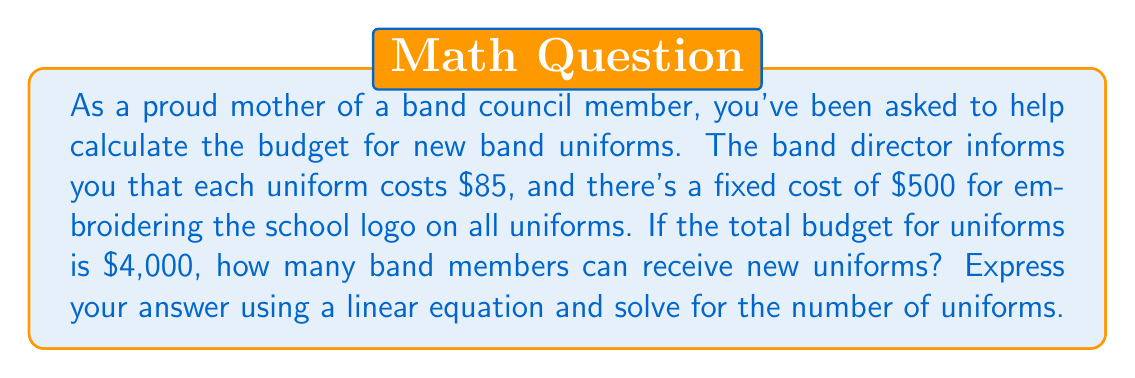Show me your answer to this math problem. Let's approach this step-by-step:

1) Let $x$ represent the number of uniforms.

2) We can express the total cost as a linear equation:
   $$ \text{Total Cost} = \text{Fixed Cost} + (\text{Cost per Uniform} \times \text{Number of Uniforms}) $$

3) Substituting the given values:
   $$ 4000 = 500 + 85x $$

4) To solve for $x$, first subtract 500 from both sides:
   $$ 3500 = 85x $$

5) Now divide both sides by 85:
   $$ \frac{3500}{85} = x $$

6) Calculate the result:
   $$ x = 41.176... $$

7) Since we can't have a fractional number of uniforms, we round down to the nearest whole number.
Answer: The linear equation is: $4000 = 500 + 85x$, where $x$ is the number of uniforms.
Solving this equation, we find that $x = 41$ (rounded down).
Therefore, 41 band members can receive new uniforms within the $4,000 budget. 